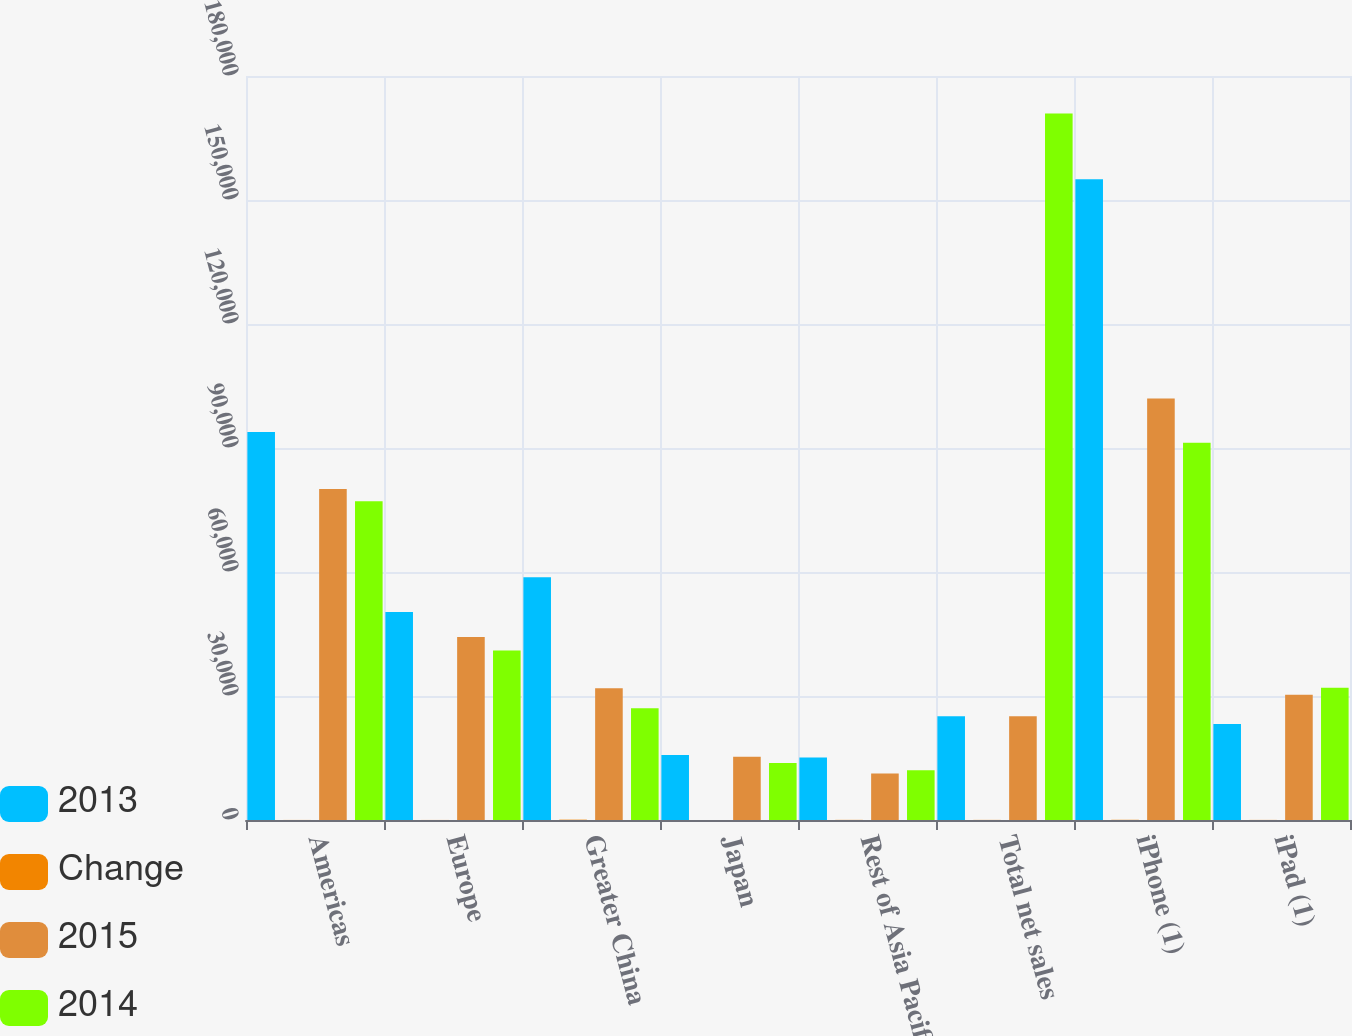<chart> <loc_0><loc_0><loc_500><loc_500><stacked_bar_chart><ecel><fcel>Americas<fcel>Europe<fcel>Greater China<fcel>Japan<fcel>Rest of Asia Pacific<fcel>Total net sales<fcel>iPhone (1)<fcel>iPad (1)<nl><fcel>2013<fcel>93864<fcel>50337<fcel>58715<fcel>15706<fcel>15093<fcel>25121.5<fcel>155041<fcel>23227<nl><fcel>Change<fcel>17<fcel>14<fcel>84<fcel>3<fcel>34<fcel>28<fcel>52<fcel>23<nl><fcel>2015<fcel>80095<fcel>44285<fcel>31853<fcel>15314<fcel>11248<fcel>25121.5<fcel>101991<fcel>30283<nl><fcel>2014<fcel>77093<fcel>40980<fcel>27016<fcel>13782<fcel>12039<fcel>170910<fcel>91279<fcel>31980<nl></chart> 